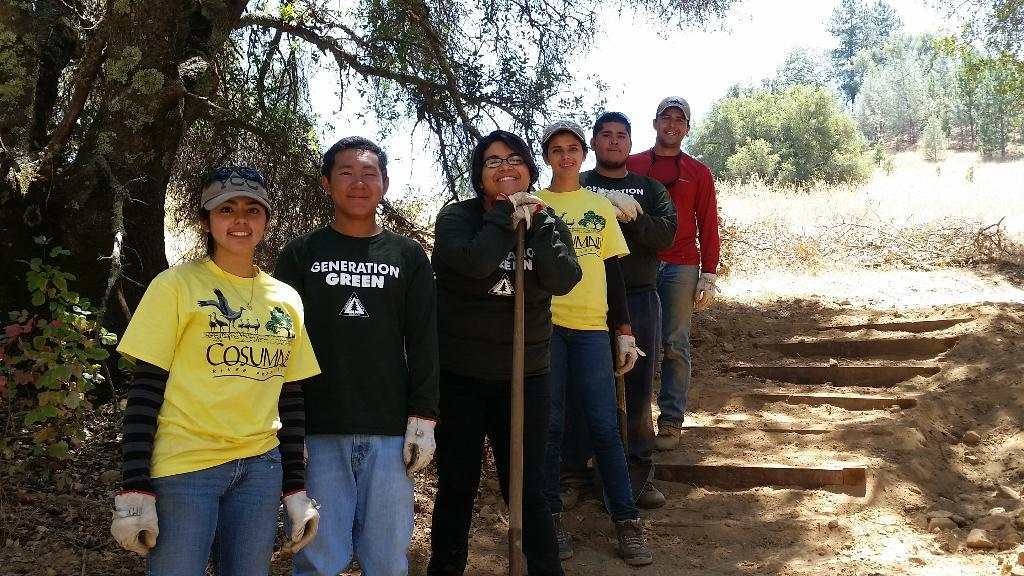What are the people in the image doing? The people in the center of the image are standing and smiling. What can be seen in the background of the image? There are trees and the sky visible in the background of the image. What architectural feature is present on the right side of the image? There are stairs on the right side of the image. What type of corn can be seen growing on the stairs in the image? There is no corn present in the image, and the stairs do not have any plants growing on them. 